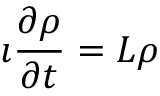Convert formula to latex. <formula><loc_0><loc_0><loc_500><loc_500>\imath \frac { \partial \rho } { \partial t } = L \rho</formula> 